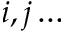Convert formula to latex. <formula><loc_0><loc_0><loc_500><loc_500>i , j \dots</formula> 